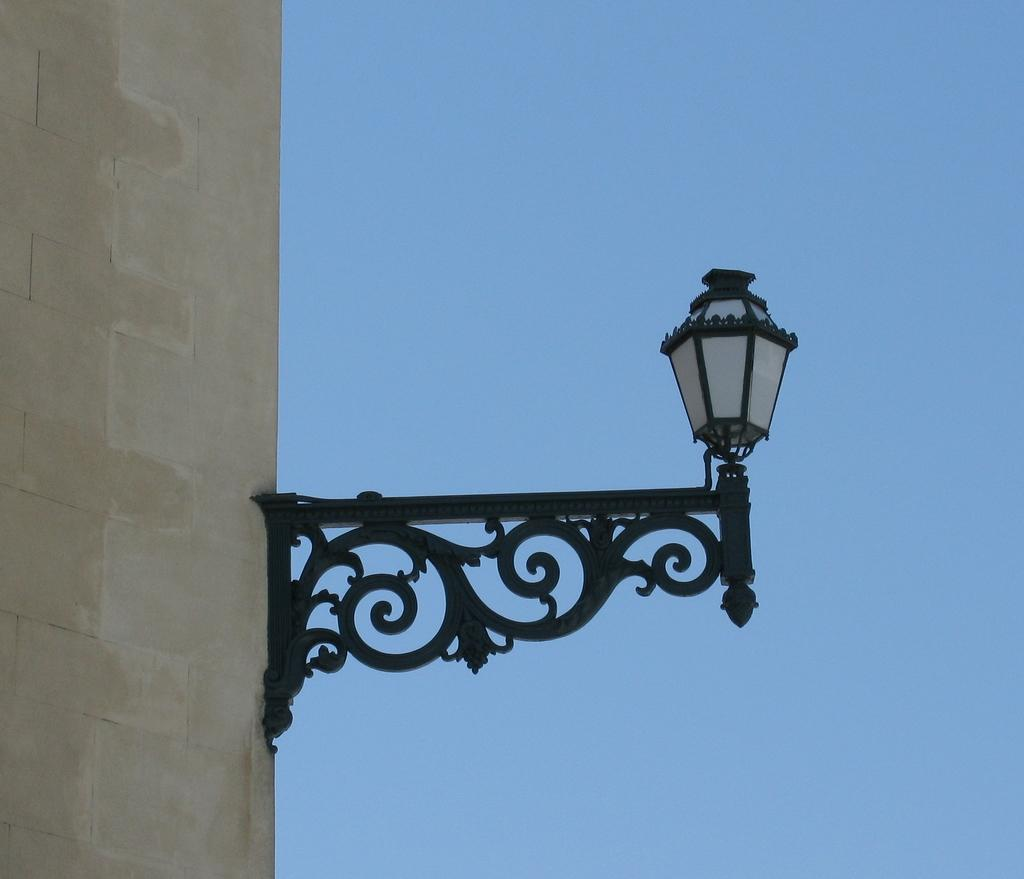What type of object is in the image? There is a vintage lamp in the image. How is the lamp connected to the building? The lamp is attached to a building stock. What type of plate is used to cover the lamp in the image? There is no plate present in the image, as it features a vintage lamp attached to a building stock. 